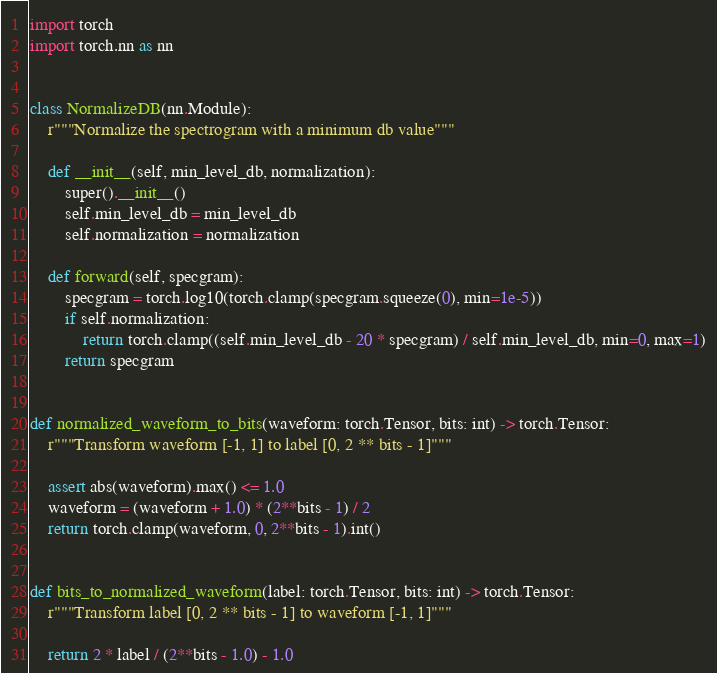<code> <loc_0><loc_0><loc_500><loc_500><_Python_>import torch
import torch.nn as nn


class NormalizeDB(nn.Module):
    r"""Normalize the spectrogram with a minimum db value"""

    def __init__(self, min_level_db, normalization):
        super().__init__()
        self.min_level_db = min_level_db
        self.normalization = normalization

    def forward(self, specgram):
        specgram = torch.log10(torch.clamp(specgram.squeeze(0), min=1e-5))
        if self.normalization:
            return torch.clamp((self.min_level_db - 20 * specgram) / self.min_level_db, min=0, max=1)
        return specgram


def normalized_waveform_to_bits(waveform: torch.Tensor, bits: int) -> torch.Tensor:
    r"""Transform waveform [-1, 1] to label [0, 2 ** bits - 1]"""

    assert abs(waveform).max() <= 1.0
    waveform = (waveform + 1.0) * (2**bits - 1) / 2
    return torch.clamp(waveform, 0, 2**bits - 1).int()


def bits_to_normalized_waveform(label: torch.Tensor, bits: int) -> torch.Tensor:
    r"""Transform label [0, 2 ** bits - 1] to waveform [-1, 1]"""

    return 2 * label / (2**bits - 1.0) - 1.0
</code> 